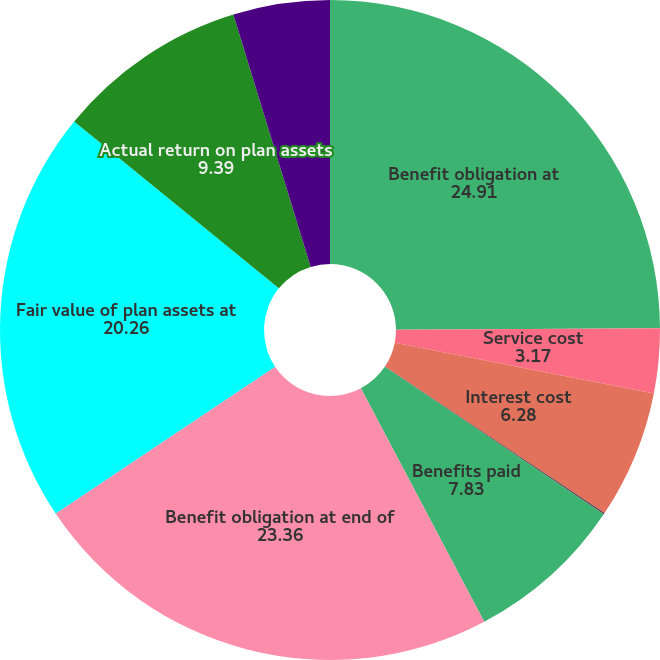<chart> <loc_0><loc_0><loc_500><loc_500><pie_chart><fcel>Benefit obligation at<fcel>Service cost<fcel>Interest cost<fcel>Actuarial (gain) loss<fcel>Benefits paid<fcel>Benefit obligation at end of<fcel>Fair value of plan assets at<fcel>Actual return on plan assets<fcel>Contributions<nl><fcel>24.91%<fcel>3.17%<fcel>6.28%<fcel>0.07%<fcel>7.83%<fcel>23.36%<fcel>20.26%<fcel>9.39%<fcel>4.73%<nl></chart> 